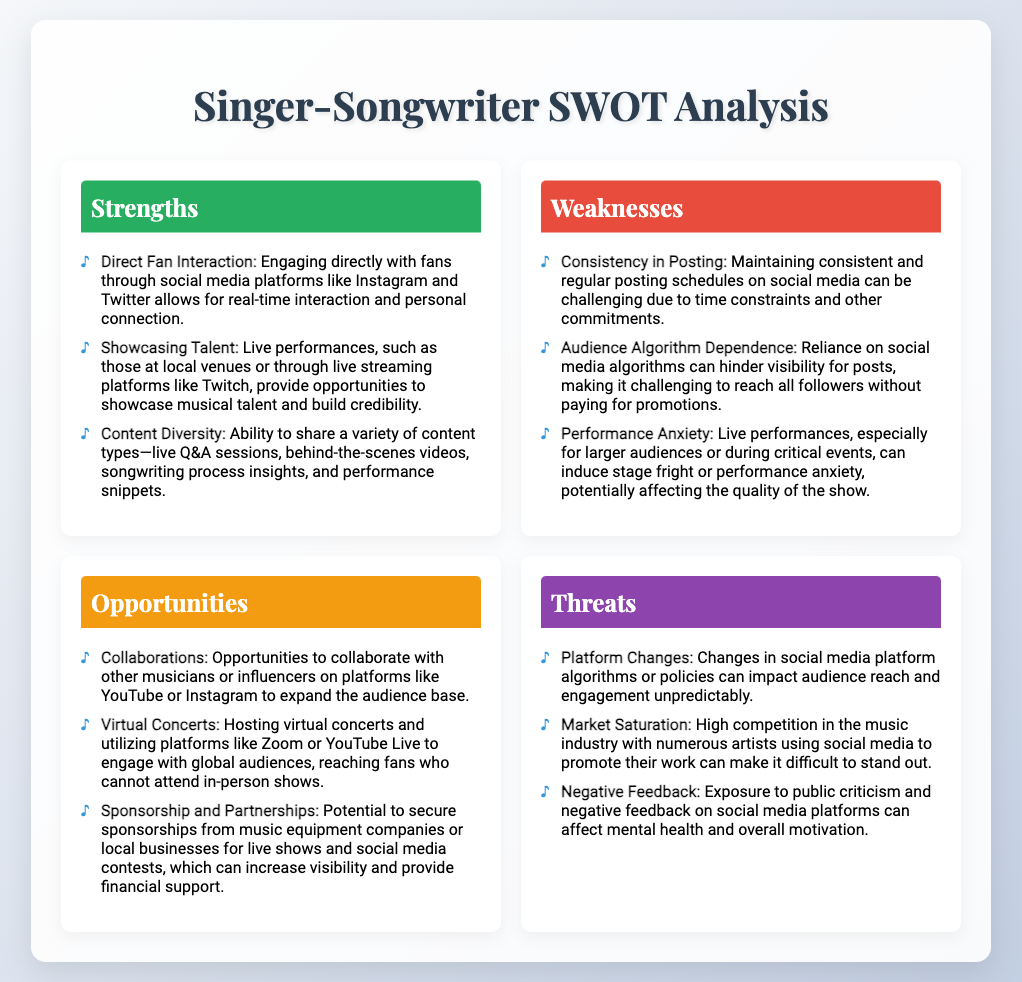What are the strengths mentioned? Key strengths listed include direct fan interaction, showcasing talent, and content diversity.
Answer: Direct Fan Interaction, Showcasing Talent, Content Diversity What is a weakness related to social media? One specified weakness is the challenge of maintaining consistent and regular posting schedules on social media.
Answer: Consistency in Posting What opportunity involves global engagement? The opportunity to host virtual concerts engages global audiences who cannot attend in-person shows.
Answer: Virtual Concerts What are the threats mentioned regarding platform changes? The document notes that changes in social media platform algorithms or policies can impact audience reach and engagement.
Answer: Platform Changes What is a potential source of sponsorship? The document mentions sponsorships from music equipment companies as a potential source for financial support.
Answer: Music equipment companies How many opportunities are listed in the analysis? The analysis details three distinct opportunities regarding audience engagement.
Answer: Three What impact does negative feedback have? Negative feedback can affect the mental health and overall motivation of the artist.
Answer: Mental health and motivation Which strength highlights the personal connection with fans? Engaging directly with fans through social media platforms highlights a personal connection.
Answer: Direct Fan Interaction 